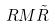Convert formula to latex. <formula><loc_0><loc_0><loc_500><loc_500>R M \tilde { R }</formula> 